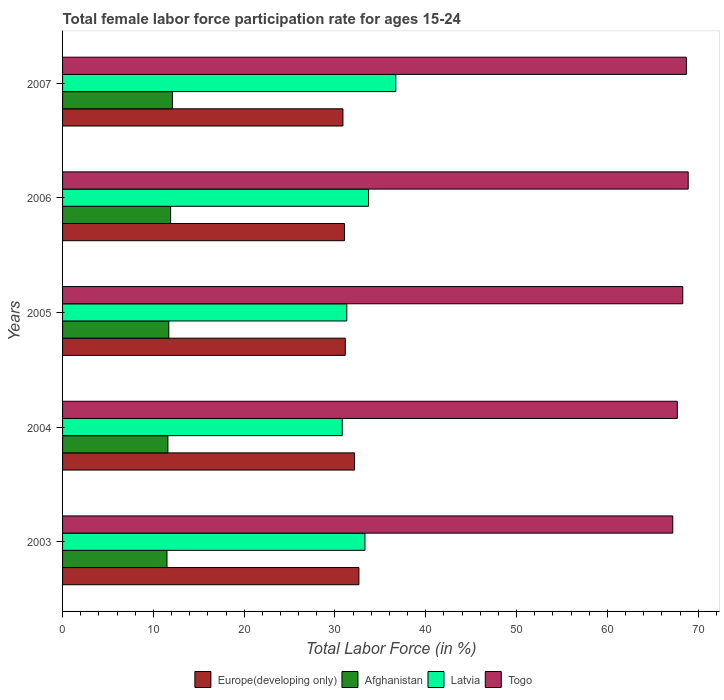How many groups of bars are there?
Provide a short and direct response. 5. Are the number of bars on each tick of the Y-axis equal?
Your answer should be compact. Yes. How many bars are there on the 5th tick from the top?
Make the answer very short. 4. How many bars are there on the 4th tick from the bottom?
Your answer should be compact. 4. What is the label of the 3rd group of bars from the top?
Give a very brief answer. 2005. In how many cases, is the number of bars for a given year not equal to the number of legend labels?
Your response must be concise. 0. What is the female labor force participation rate in Togo in 2003?
Provide a short and direct response. 67.2. Across all years, what is the maximum female labor force participation rate in Europe(developing only)?
Offer a terse response. 32.63. Across all years, what is the minimum female labor force participation rate in Europe(developing only)?
Give a very brief answer. 30.88. In which year was the female labor force participation rate in Latvia minimum?
Give a very brief answer. 2004. What is the total female labor force participation rate in Togo in the graph?
Make the answer very short. 340.8. What is the difference between the female labor force participation rate in Togo in 2004 and the female labor force participation rate in Latvia in 2003?
Offer a terse response. 34.4. What is the average female labor force participation rate in Togo per year?
Your answer should be very brief. 68.16. In the year 2004, what is the difference between the female labor force participation rate in Togo and female labor force participation rate in Afghanistan?
Give a very brief answer. 56.1. What is the ratio of the female labor force participation rate in Afghanistan in 2005 to that in 2007?
Make the answer very short. 0.97. Is the female labor force participation rate in Europe(developing only) in 2004 less than that in 2006?
Offer a terse response. No. What is the difference between the highest and the second highest female labor force participation rate in Europe(developing only)?
Your answer should be very brief. 0.48. What is the difference between the highest and the lowest female labor force participation rate in Togo?
Your answer should be compact. 1.7. In how many years, is the female labor force participation rate in Afghanistan greater than the average female labor force participation rate in Afghanistan taken over all years?
Provide a succinct answer. 2. Is the sum of the female labor force participation rate in Europe(developing only) in 2005 and 2007 greater than the maximum female labor force participation rate in Togo across all years?
Give a very brief answer. No. Is it the case that in every year, the sum of the female labor force participation rate in Afghanistan and female labor force participation rate in Latvia is greater than the sum of female labor force participation rate in Europe(developing only) and female labor force participation rate in Togo?
Offer a terse response. Yes. What does the 4th bar from the top in 2006 represents?
Offer a very short reply. Europe(developing only). What does the 2nd bar from the bottom in 2004 represents?
Offer a terse response. Afghanistan. Is it the case that in every year, the sum of the female labor force participation rate in Latvia and female labor force participation rate in Europe(developing only) is greater than the female labor force participation rate in Afghanistan?
Your answer should be very brief. Yes. How many years are there in the graph?
Offer a terse response. 5. What is the difference between two consecutive major ticks on the X-axis?
Your answer should be very brief. 10. Are the values on the major ticks of X-axis written in scientific E-notation?
Keep it short and to the point. No. Does the graph contain grids?
Give a very brief answer. No. Where does the legend appear in the graph?
Your answer should be compact. Bottom center. What is the title of the graph?
Your answer should be very brief. Total female labor force participation rate for ages 15-24. Does "Morocco" appear as one of the legend labels in the graph?
Your answer should be very brief. No. What is the Total Labor Force (in %) in Europe(developing only) in 2003?
Keep it short and to the point. 32.63. What is the Total Labor Force (in %) of Latvia in 2003?
Keep it short and to the point. 33.3. What is the Total Labor Force (in %) in Togo in 2003?
Provide a succinct answer. 67.2. What is the Total Labor Force (in %) of Europe(developing only) in 2004?
Make the answer very short. 32.16. What is the Total Labor Force (in %) of Afghanistan in 2004?
Offer a terse response. 11.6. What is the Total Labor Force (in %) of Latvia in 2004?
Give a very brief answer. 30.8. What is the Total Labor Force (in %) of Togo in 2004?
Your answer should be very brief. 67.7. What is the Total Labor Force (in %) of Europe(developing only) in 2005?
Offer a very short reply. 31.13. What is the Total Labor Force (in %) of Afghanistan in 2005?
Provide a short and direct response. 11.7. What is the Total Labor Force (in %) in Latvia in 2005?
Your response must be concise. 31.3. What is the Total Labor Force (in %) of Togo in 2005?
Your answer should be compact. 68.3. What is the Total Labor Force (in %) in Europe(developing only) in 2006?
Keep it short and to the point. 31.05. What is the Total Labor Force (in %) of Afghanistan in 2006?
Make the answer very short. 11.9. What is the Total Labor Force (in %) in Latvia in 2006?
Your answer should be very brief. 33.7. What is the Total Labor Force (in %) of Togo in 2006?
Offer a very short reply. 68.9. What is the Total Labor Force (in %) of Europe(developing only) in 2007?
Make the answer very short. 30.88. What is the Total Labor Force (in %) of Afghanistan in 2007?
Offer a very short reply. 12.1. What is the Total Labor Force (in %) of Latvia in 2007?
Your answer should be compact. 36.7. What is the Total Labor Force (in %) of Togo in 2007?
Ensure brevity in your answer.  68.7. Across all years, what is the maximum Total Labor Force (in %) in Europe(developing only)?
Your answer should be compact. 32.63. Across all years, what is the maximum Total Labor Force (in %) in Afghanistan?
Provide a short and direct response. 12.1. Across all years, what is the maximum Total Labor Force (in %) of Latvia?
Your answer should be very brief. 36.7. Across all years, what is the maximum Total Labor Force (in %) of Togo?
Provide a short and direct response. 68.9. Across all years, what is the minimum Total Labor Force (in %) of Europe(developing only)?
Your answer should be very brief. 30.88. Across all years, what is the minimum Total Labor Force (in %) in Afghanistan?
Offer a terse response. 11.5. Across all years, what is the minimum Total Labor Force (in %) in Latvia?
Ensure brevity in your answer.  30.8. Across all years, what is the minimum Total Labor Force (in %) of Togo?
Make the answer very short. 67.2. What is the total Total Labor Force (in %) of Europe(developing only) in the graph?
Provide a short and direct response. 157.85. What is the total Total Labor Force (in %) in Afghanistan in the graph?
Keep it short and to the point. 58.8. What is the total Total Labor Force (in %) in Latvia in the graph?
Your answer should be very brief. 165.8. What is the total Total Labor Force (in %) in Togo in the graph?
Make the answer very short. 340.8. What is the difference between the Total Labor Force (in %) in Europe(developing only) in 2003 and that in 2004?
Your answer should be compact. 0.48. What is the difference between the Total Labor Force (in %) of Afghanistan in 2003 and that in 2004?
Give a very brief answer. -0.1. What is the difference between the Total Labor Force (in %) in Europe(developing only) in 2003 and that in 2005?
Provide a short and direct response. 1.5. What is the difference between the Total Labor Force (in %) in Latvia in 2003 and that in 2005?
Give a very brief answer. 2. What is the difference between the Total Labor Force (in %) in Europe(developing only) in 2003 and that in 2006?
Your answer should be compact. 1.59. What is the difference between the Total Labor Force (in %) in Latvia in 2003 and that in 2006?
Provide a succinct answer. -0.4. What is the difference between the Total Labor Force (in %) of Europe(developing only) in 2003 and that in 2007?
Offer a very short reply. 1.76. What is the difference between the Total Labor Force (in %) of Afghanistan in 2003 and that in 2007?
Your response must be concise. -0.6. What is the difference between the Total Labor Force (in %) in Latvia in 2003 and that in 2007?
Offer a terse response. -3.4. What is the difference between the Total Labor Force (in %) of Europe(developing only) in 2004 and that in 2005?
Make the answer very short. 1.02. What is the difference between the Total Labor Force (in %) in Europe(developing only) in 2004 and that in 2006?
Your response must be concise. 1.11. What is the difference between the Total Labor Force (in %) in Europe(developing only) in 2004 and that in 2007?
Your response must be concise. 1.28. What is the difference between the Total Labor Force (in %) in Togo in 2004 and that in 2007?
Offer a terse response. -1. What is the difference between the Total Labor Force (in %) of Europe(developing only) in 2005 and that in 2006?
Give a very brief answer. 0.09. What is the difference between the Total Labor Force (in %) of Afghanistan in 2005 and that in 2006?
Offer a terse response. -0.2. What is the difference between the Total Labor Force (in %) in Togo in 2005 and that in 2006?
Your answer should be compact. -0.6. What is the difference between the Total Labor Force (in %) in Europe(developing only) in 2005 and that in 2007?
Offer a very short reply. 0.26. What is the difference between the Total Labor Force (in %) of Latvia in 2005 and that in 2007?
Make the answer very short. -5.4. What is the difference between the Total Labor Force (in %) in Togo in 2005 and that in 2007?
Keep it short and to the point. -0.4. What is the difference between the Total Labor Force (in %) of Europe(developing only) in 2006 and that in 2007?
Your response must be concise. 0.17. What is the difference between the Total Labor Force (in %) of Europe(developing only) in 2003 and the Total Labor Force (in %) of Afghanistan in 2004?
Offer a very short reply. 21.03. What is the difference between the Total Labor Force (in %) of Europe(developing only) in 2003 and the Total Labor Force (in %) of Latvia in 2004?
Your answer should be very brief. 1.83. What is the difference between the Total Labor Force (in %) of Europe(developing only) in 2003 and the Total Labor Force (in %) of Togo in 2004?
Provide a short and direct response. -35.07. What is the difference between the Total Labor Force (in %) of Afghanistan in 2003 and the Total Labor Force (in %) of Latvia in 2004?
Your answer should be very brief. -19.3. What is the difference between the Total Labor Force (in %) in Afghanistan in 2003 and the Total Labor Force (in %) in Togo in 2004?
Your answer should be compact. -56.2. What is the difference between the Total Labor Force (in %) in Latvia in 2003 and the Total Labor Force (in %) in Togo in 2004?
Provide a succinct answer. -34.4. What is the difference between the Total Labor Force (in %) of Europe(developing only) in 2003 and the Total Labor Force (in %) of Afghanistan in 2005?
Give a very brief answer. 20.93. What is the difference between the Total Labor Force (in %) of Europe(developing only) in 2003 and the Total Labor Force (in %) of Latvia in 2005?
Ensure brevity in your answer.  1.33. What is the difference between the Total Labor Force (in %) in Europe(developing only) in 2003 and the Total Labor Force (in %) in Togo in 2005?
Your answer should be very brief. -35.67. What is the difference between the Total Labor Force (in %) of Afghanistan in 2003 and the Total Labor Force (in %) of Latvia in 2005?
Offer a terse response. -19.8. What is the difference between the Total Labor Force (in %) in Afghanistan in 2003 and the Total Labor Force (in %) in Togo in 2005?
Keep it short and to the point. -56.8. What is the difference between the Total Labor Force (in %) in Latvia in 2003 and the Total Labor Force (in %) in Togo in 2005?
Give a very brief answer. -35. What is the difference between the Total Labor Force (in %) of Europe(developing only) in 2003 and the Total Labor Force (in %) of Afghanistan in 2006?
Your answer should be compact. 20.73. What is the difference between the Total Labor Force (in %) of Europe(developing only) in 2003 and the Total Labor Force (in %) of Latvia in 2006?
Make the answer very short. -1.07. What is the difference between the Total Labor Force (in %) of Europe(developing only) in 2003 and the Total Labor Force (in %) of Togo in 2006?
Your answer should be very brief. -36.27. What is the difference between the Total Labor Force (in %) of Afghanistan in 2003 and the Total Labor Force (in %) of Latvia in 2006?
Ensure brevity in your answer.  -22.2. What is the difference between the Total Labor Force (in %) in Afghanistan in 2003 and the Total Labor Force (in %) in Togo in 2006?
Your response must be concise. -57.4. What is the difference between the Total Labor Force (in %) in Latvia in 2003 and the Total Labor Force (in %) in Togo in 2006?
Your answer should be compact. -35.6. What is the difference between the Total Labor Force (in %) in Europe(developing only) in 2003 and the Total Labor Force (in %) in Afghanistan in 2007?
Offer a terse response. 20.53. What is the difference between the Total Labor Force (in %) in Europe(developing only) in 2003 and the Total Labor Force (in %) in Latvia in 2007?
Your answer should be very brief. -4.07. What is the difference between the Total Labor Force (in %) of Europe(developing only) in 2003 and the Total Labor Force (in %) of Togo in 2007?
Offer a terse response. -36.07. What is the difference between the Total Labor Force (in %) in Afghanistan in 2003 and the Total Labor Force (in %) in Latvia in 2007?
Offer a very short reply. -25.2. What is the difference between the Total Labor Force (in %) of Afghanistan in 2003 and the Total Labor Force (in %) of Togo in 2007?
Offer a terse response. -57.2. What is the difference between the Total Labor Force (in %) of Latvia in 2003 and the Total Labor Force (in %) of Togo in 2007?
Offer a terse response. -35.4. What is the difference between the Total Labor Force (in %) in Europe(developing only) in 2004 and the Total Labor Force (in %) in Afghanistan in 2005?
Your response must be concise. 20.46. What is the difference between the Total Labor Force (in %) of Europe(developing only) in 2004 and the Total Labor Force (in %) of Latvia in 2005?
Offer a terse response. 0.86. What is the difference between the Total Labor Force (in %) of Europe(developing only) in 2004 and the Total Labor Force (in %) of Togo in 2005?
Ensure brevity in your answer.  -36.14. What is the difference between the Total Labor Force (in %) of Afghanistan in 2004 and the Total Labor Force (in %) of Latvia in 2005?
Offer a terse response. -19.7. What is the difference between the Total Labor Force (in %) of Afghanistan in 2004 and the Total Labor Force (in %) of Togo in 2005?
Keep it short and to the point. -56.7. What is the difference between the Total Labor Force (in %) in Latvia in 2004 and the Total Labor Force (in %) in Togo in 2005?
Keep it short and to the point. -37.5. What is the difference between the Total Labor Force (in %) of Europe(developing only) in 2004 and the Total Labor Force (in %) of Afghanistan in 2006?
Provide a succinct answer. 20.26. What is the difference between the Total Labor Force (in %) of Europe(developing only) in 2004 and the Total Labor Force (in %) of Latvia in 2006?
Provide a short and direct response. -1.54. What is the difference between the Total Labor Force (in %) in Europe(developing only) in 2004 and the Total Labor Force (in %) in Togo in 2006?
Provide a short and direct response. -36.74. What is the difference between the Total Labor Force (in %) of Afghanistan in 2004 and the Total Labor Force (in %) of Latvia in 2006?
Offer a very short reply. -22.1. What is the difference between the Total Labor Force (in %) in Afghanistan in 2004 and the Total Labor Force (in %) in Togo in 2006?
Provide a short and direct response. -57.3. What is the difference between the Total Labor Force (in %) of Latvia in 2004 and the Total Labor Force (in %) of Togo in 2006?
Offer a terse response. -38.1. What is the difference between the Total Labor Force (in %) of Europe(developing only) in 2004 and the Total Labor Force (in %) of Afghanistan in 2007?
Offer a terse response. 20.06. What is the difference between the Total Labor Force (in %) of Europe(developing only) in 2004 and the Total Labor Force (in %) of Latvia in 2007?
Provide a succinct answer. -4.54. What is the difference between the Total Labor Force (in %) in Europe(developing only) in 2004 and the Total Labor Force (in %) in Togo in 2007?
Offer a terse response. -36.54. What is the difference between the Total Labor Force (in %) in Afghanistan in 2004 and the Total Labor Force (in %) in Latvia in 2007?
Ensure brevity in your answer.  -25.1. What is the difference between the Total Labor Force (in %) of Afghanistan in 2004 and the Total Labor Force (in %) of Togo in 2007?
Offer a very short reply. -57.1. What is the difference between the Total Labor Force (in %) in Latvia in 2004 and the Total Labor Force (in %) in Togo in 2007?
Make the answer very short. -37.9. What is the difference between the Total Labor Force (in %) in Europe(developing only) in 2005 and the Total Labor Force (in %) in Afghanistan in 2006?
Your answer should be very brief. 19.23. What is the difference between the Total Labor Force (in %) of Europe(developing only) in 2005 and the Total Labor Force (in %) of Latvia in 2006?
Your answer should be very brief. -2.57. What is the difference between the Total Labor Force (in %) of Europe(developing only) in 2005 and the Total Labor Force (in %) of Togo in 2006?
Your answer should be compact. -37.77. What is the difference between the Total Labor Force (in %) of Afghanistan in 2005 and the Total Labor Force (in %) of Latvia in 2006?
Your answer should be very brief. -22. What is the difference between the Total Labor Force (in %) in Afghanistan in 2005 and the Total Labor Force (in %) in Togo in 2006?
Your answer should be very brief. -57.2. What is the difference between the Total Labor Force (in %) in Latvia in 2005 and the Total Labor Force (in %) in Togo in 2006?
Offer a terse response. -37.6. What is the difference between the Total Labor Force (in %) in Europe(developing only) in 2005 and the Total Labor Force (in %) in Afghanistan in 2007?
Provide a succinct answer. 19.03. What is the difference between the Total Labor Force (in %) of Europe(developing only) in 2005 and the Total Labor Force (in %) of Latvia in 2007?
Keep it short and to the point. -5.57. What is the difference between the Total Labor Force (in %) in Europe(developing only) in 2005 and the Total Labor Force (in %) in Togo in 2007?
Provide a short and direct response. -37.57. What is the difference between the Total Labor Force (in %) of Afghanistan in 2005 and the Total Labor Force (in %) of Togo in 2007?
Your answer should be very brief. -57. What is the difference between the Total Labor Force (in %) in Latvia in 2005 and the Total Labor Force (in %) in Togo in 2007?
Make the answer very short. -37.4. What is the difference between the Total Labor Force (in %) in Europe(developing only) in 2006 and the Total Labor Force (in %) in Afghanistan in 2007?
Your answer should be very brief. 18.95. What is the difference between the Total Labor Force (in %) in Europe(developing only) in 2006 and the Total Labor Force (in %) in Latvia in 2007?
Your answer should be compact. -5.65. What is the difference between the Total Labor Force (in %) of Europe(developing only) in 2006 and the Total Labor Force (in %) of Togo in 2007?
Your response must be concise. -37.65. What is the difference between the Total Labor Force (in %) of Afghanistan in 2006 and the Total Labor Force (in %) of Latvia in 2007?
Offer a very short reply. -24.8. What is the difference between the Total Labor Force (in %) of Afghanistan in 2006 and the Total Labor Force (in %) of Togo in 2007?
Provide a short and direct response. -56.8. What is the difference between the Total Labor Force (in %) of Latvia in 2006 and the Total Labor Force (in %) of Togo in 2007?
Make the answer very short. -35. What is the average Total Labor Force (in %) of Europe(developing only) per year?
Make the answer very short. 31.57. What is the average Total Labor Force (in %) of Afghanistan per year?
Your answer should be very brief. 11.76. What is the average Total Labor Force (in %) in Latvia per year?
Provide a short and direct response. 33.16. What is the average Total Labor Force (in %) in Togo per year?
Make the answer very short. 68.16. In the year 2003, what is the difference between the Total Labor Force (in %) of Europe(developing only) and Total Labor Force (in %) of Afghanistan?
Give a very brief answer. 21.13. In the year 2003, what is the difference between the Total Labor Force (in %) of Europe(developing only) and Total Labor Force (in %) of Latvia?
Make the answer very short. -0.67. In the year 2003, what is the difference between the Total Labor Force (in %) in Europe(developing only) and Total Labor Force (in %) in Togo?
Offer a terse response. -34.57. In the year 2003, what is the difference between the Total Labor Force (in %) in Afghanistan and Total Labor Force (in %) in Latvia?
Give a very brief answer. -21.8. In the year 2003, what is the difference between the Total Labor Force (in %) in Afghanistan and Total Labor Force (in %) in Togo?
Give a very brief answer. -55.7. In the year 2003, what is the difference between the Total Labor Force (in %) of Latvia and Total Labor Force (in %) of Togo?
Offer a terse response. -33.9. In the year 2004, what is the difference between the Total Labor Force (in %) in Europe(developing only) and Total Labor Force (in %) in Afghanistan?
Offer a very short reply. 20.56. In the year 2004, what is the difference between the Total Labor Force (in %) in Europe(developing only) and Total Labor Force (in %) in Latvia?
Keep it short and to the point. 1.36. In the year 2004, what is the difference between the Total Labor Force (in %) in Europe(developing only) and Total Labor Force (in %) in Togo?
Your response must be concise. -35.54. In the year 2004, what is the difference between the Total Labor Force (in %) in Afghanistan and Total Labor Force (in %) in Latvia?
Give a very brief answer. -19.2. In the year 2004, what is the difference between the Total Labor Force (in %) in Afghanistan and Total Labor Force (in %) in Togo?
Make the answer very short. -56.1. In the year 2004, what is the difference between the Total Labor Force (in %) in Latvia and Total Labor Force (in %) in Togo?
Ensure brevity in your answer.  -36.9. In the year 2005, what is the difference between the Total Labor Force (in %) in Europe(developing only) and Total Labor Force (in %) in Afghanistan?
Ensure brevity in your answer.  19.43. In the year 2005, what is the difference between the Total Labor Force (in %) in Europe(developing only) and Total Labor Force (in %) in Latvia?
Provide a short and direct response. -0.17. In the year 2005, what is the difference between the Total Labor Force (in %) of Europe(developing only) and Total Labor Force (in %) of Togo?
Provide a succinct answer. -37.17. In the year 2005, what is the difference between the Total Labor Force (in %) of Afghanistan and Total Labor Force (in %) of Latvia?
Keep it short and to the point. -19.6. In the year 2005, what is the difference between the Total Labor Force (in %) in Afghanistan and Total Labor Force (in %) in Togo?
Ensure brevity in your answer.  -56.6. In the year 2005, what is the difference between the Total Labor Force (in %) of Latvia and Total Labor Force (in %) of Togo?
Offer a terse response. -37. In the year 2006, what is the difference between the Total Labor Force (in %) in Europe(developing only) and Total Labor Force (in %) in Afghanistan?
Give a very brief answer. 19.15. In the year 2006, what is the difference between the Total Labor Force (in %) in Europe(developing only) and Total Labor Force (in %) in Latvia?
Make the answer very short. -2.65. In the year 2006, what is the difference between the Total Labor Force (in %) of Europe(developing only) and Total Labor Force (in %) of Togo?
Your response must be concise. -37.85. In the year 2006, what is the difference between the Total Labor Force (in %) of Afghanistan and Total Labor Force (in %) of Latvia?
Provide a short and direct response. -21.8. In the year 2006, what is the difference between the Total Labor Force (in %) in Afghanistan and Total Labor Force (in %) in Togo?
Make the answer very short. -57. In the year 2006, what is the difference between the Total Labor Force (in %) in Latvia and Total Labor Force (in %) in Togo?
Give a very brief answer. -35.2. In the year 2007, what is the difference between the Total Labor Force (in %) of Europe(developing only) and Total Labor Force (in %) of Afghanistan?
Your answer should be very brief. 18.78. In the year 2007, what is the difference between the Total Labor Force (in %) in Europe(developing only) and Total Labor Force (in %) in Latvia?
Keep it short and to the point. -5.82. In the year 2007, what is the difference between the Total Labor Force (in %) of Europe(developing only) and Total Labor Force (in %) of Togo?
Make the answer very short. -37.82. In the year 2007, what is the difference between the Total Labor Force (in %) of Afghanistan and Total Labor Force (in %) of Latvia?
Ensure brevity in your answer.  -24.6. In the year 2007, what is the difference between the Total Labor Force (in %) of Afghanistan and Total Labor Force (in %) of Togo?
Provide a succinct answer. -56.6. In the year 2007, what is the difference between the Total Labor Force (in %) in Latvia and Total Labor Force (in %) in Togo?
Your response must be concise. -32. What is the ratio of the Total Labor Force (in %) of Europe(developing only) in 2003 to that in 2004?
Provide a succinct answer. 1.01. What is the ratio of the Total Labor Force (in %) in Afghanistan in 2003 to that in 2004?
Your answer should be very brief. 0.99. What is the ratio of the Total Labor Force (in %) in Latvia in 2003 to that in 2004?
Offer a terse response. 1.08. What is the ratio of the Total Labor Force (in %) of Togo in 2003 to that in 2004?
Keep it short and to the point. 0.99. What is the ratio of the Total Labor Force (in %) of Europe(developing only) in 2003 to that in 2005?
Offer a terse response. 1.05. What is the ratio of the Total Labor Force (in %) in Afghanistan in 2003 to that in 2005?
Give a very brief answer. 0.98. What is the ratio of the Total Labor Force (in %) of Latvia in 2003 to that in 2005?
Offer a very short reply. 1.06. What is the ratio of the Total Labor Force (in %) in Togo in 2003 to that in 2005?
Provide a succinct answer. 0.98. What is the ratio of the Total Labor Force (in %) of Europe(developing only) in 2003 to that in 2006?
Your answer should be very brief. 1.05. What is the ratio of the Total Labor Force (in %) in Afghanistan in 2003 to that in 2006?
Offer a terse response. 0.97. What is the ratio of the Total Labor Force (in %) in Latvia in 2003 to that in 2006?
Give a very brief answer. 0.99. What is the ratio of the Total Labor Force (in %) of Togo in 2003 to that in 2006?
Your response must be concise. 0.98. What is the ratio of the Total Labor Force (in %) in Europe(developing only) in 2003 to that in 2007?
Give a very brief answer. 1.06. What is the ratio of the Total Labor Force (in %) of Afghanistan in 2003 to that in 2007?
Provide a succinct answer. 0.95. What is the ratio of the Total Labor Force (in %) of Latvia in 2003 to that in 2007?
Offer a very short reply. 0.91. What is the ratio of the Total Labor Force (in %) of Togo in 2003 to that in 2007?
Offer a very short reply. 0.98. What is the ratio of the Total Labor Force (in %) in Europe(developing only) in 2004 to that in 2005?
Make the answer very short. 1.03. What is the ratio of the Total Labor Force (in %) of Afghanistan in 2004 to that in 2005?
Offer a terse response. 0.99. What is the ratio of the Total Labor Force (in %) of Latvia in 2004 to that in 2005?
Keep it short and to the point. 0.98. What is the ratio of the Total Labor Force (in %) of Europe(developing only) in 2004 to that in 2006?
Make the answer very short. 1.04. What is the ratio of the Total Labor Force (in %) in Afghanistan in 2004 to that in 2006?
Your answer should be compact. 0.97. What is the ratio of the Total Labor Force (in %) of Latvia in 2004 to that in 2006?
Offer a terse response. 0.91. What is the ratio of the Total Labor Force (in %) of Togo in 2004 to that in 2006?
Provide a short and direct response. 0.98. What is the ratio of the Total Labor Force (in %) in Europe(developing only) in 2004 to that in 2007?
Give a very brief answer. 1.04. What is the ratio of the Total Labor Force (in %) in Afghanistan in 2004 to that in 2007?
Provide a succinct answer. 0.96. What is the ratio of the Total Labor Force (in %) of Latvia in 2004 to that in 2007?
Provide a short and direct response. 0.84. What is the ratio of the Total Labor Force (in %) of Togo in 2004 to that in 2007?
Your answer should be compact. 0.99. What is the ratio of the Total Labor Force (in %) in Europe(developing only) in 2005 to that in 2006?
Give a very brief answer. 1. What is the ratio of the Total Labor Force (in %) in Afghanistan in 2005 to that in 2006?
Provide a short and direct response. 0.98. What is the ratio of the Total Labor Force (in %) of Latvia in 2005 to that in 2006?
Keep it short and to the point. 0.93. What is the ratio of the Total Labor Force (in %) in Togo in 2005 to that in 2006?
Your answer should be very brief. 0.99. What is the ratio of the Total Labor Force (in %) in Europe(developing only) in 2005 to that in 2007?
Provide a short and direct response. 1.01. What is the ratio of the Total Labor Force (in %) of Afghanistan in 2005 to that in 2007?
Provide a short and direct response. 0.97. What is the ratio of the Total Labor Force (in %) of Latvia in 2005 to that in 2007?
Your answer should be compact. 0.85. What is the ratio of the Total Labor Force (in %) of Europe(developing only) in 2006 to that in 2007?
Make the answer very short. 1.01. What is the ratio of the Total Labor Force (in %) in Afghanistan in 2006 to that in 2007?
Ensure brevity in your answer.  0.98. What is the ratio of the Total Labor Force (in %) of Latvia in 2006 to that in 2007?
Your answer should be compact. 0.92. What is the ratio of the Total Labor Force (in %) of Togo in 2006 to that in 2007?
Your answer should be compact. 1. What is the difference between the highest and the second highest Total Labor Force (in %) in Europe(developing only)?
Give a very brief answer. 0.48. What is the difference between the highest and the second highest Total Labor Force (in %) of Afghanistan?
Make the answer very short. 0.2. What is the difference between the highest and the second highest Total Labor Force (in %) of Latvia?
Your answer should be compact. 3. What is the difference between the highest and the lowest Total Labor Force (in %) of Europe(developing only)?
Keep it short and to the point. 1.76. What is the difference between the highest and the lowest Total Labor Force (in %) in Afghanistan?
Offer a terse response. 0.6. 